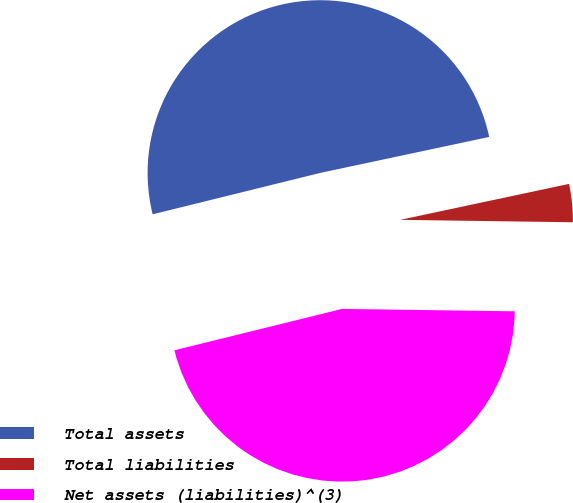Convert chart to OTSL. <chart><loc_0><loc_0><loc_500><loc_500><pie_chart><fcel>Total assets<fcel>Total liabilities<fcel>Net assets (liabilities)^(3)<nl><fcel>50.51%<fcel>3.56%<fcel>45.92%<nl></chart> 